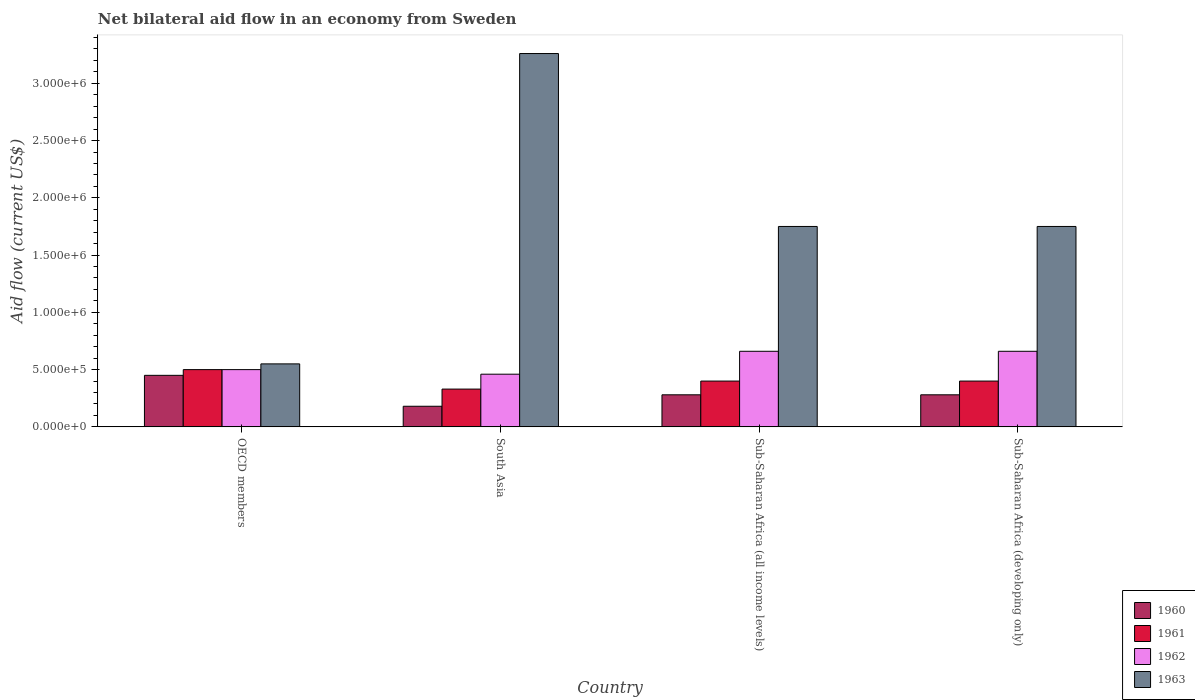How many different coloured bars are there?
Provide a succinct answer. 4. How many groups of bars are there?
Make the answer very short. 4. Are the number of bars per tick equal to the number of legend labels?
Make the answer very short. Yes. What is the label of the 4th group of bars from the left?
Ensure brevity in your answer.  Sub-Saharan Africa (developing only). In how many cases, is the number of bars for a given country not equal to the number of legend labels?
Provide a succinct answer. 0. In which country was the net bilateral aid flow in 1960 maximum?
Offer a terse response. OECD members. In which country was the net bilateral aid flow in 1963 minimum?
Your response must be concise. OECD members. What is the total net bilateral aid flow in 1960 in the graph?
Ensure brevity in your answer.  1.19e+06. What is the difference between the net bilateral aid flow in 1960 in Sub-Saharan Africa (all income levels) and that in Sub-Saharan Africa (developing only)?
Offer a terse response. 0. What is the difference between the net bilateral aid flow in 1961 in Sub-Saharan Africa (developing only) and the net bilateral aid flow in 1963 in Sub-Saharan Africa (all income levels)?
Give a very brief answer. -1.35e+06. What is the average net bilateral aid flow in 1961 per country?
Keep it short and to the point. 4.08e+05. In how many countries, is the net bilateral aid flow in 1961 greater than 200000 US$?
Provide a short and direct response. 4. What is the ratio of the net bilateral aid flow in 1962 in South Asia to that in Sub-Saharan Africa (all income levels)?
Your response must be concise. 0.7. Is the net bilateral aid flow in 1960 in South Asia less than that in Sub-Saharan Africa (all income levels)?
Make the answer very short. Yes. Is the difference between the net bilateral aid flow in 1962 in OECD members and Sub-Saharan Africa (developing only) greater than the difference between the net bilateral aid flow in 1963 in OECD members and Sub-Saharan Africa (developing only)?
Ensure brevity in your answer.  Yes. In how many countries, is the net bilateral aid flow in 1963 greater than the average net bilateral aid flow in 1963 taken over all countries?
Keep it short and to the point. 1. Is the sum of the net bilateral aid flow in 1963 in OECD members and South Asia greater than the maximum net bilateral aid flow in 1961 across all countries?
Give a very brief answer. Yes. Is it the case that in every country, the sum of the net bilateral aid flow in 1960 and net bilateral aid flow in 1961 is greater than the net bilateral aid flow in 1962?
Offer a terse response. Yes. How many bars are there?
Your answer should be compact. 16. Where does the legend appear in the graph?
Offer a very short reply. Bottom right. What is the title of the graph?
Ensure brevity in your answer.  Net bilateral aid flow in an economy from Sweden. What is the label or title of the X-axis?
Your answer should be compact. Country. What is the label or title of the Y-axis?
Give a very brief answer. Aid flow (current US$). What is the Aid flow (current US$) of 1960 in OECD members?
Give a very brief answer. 4.50e+05. What is the Aid flow (current US$) of 1963 in OECD members?
Keep it short and to the point. 5.50e+05. What is the Aid flow (current US$) of 1963 in South Asia?
Keep it short and to the point. 3.26e+06. What is the Aid flow (current US$) of 1960 in Sub-Saharan Africa (all income levels)?
Give a very brief answer. 2.80e+05. What is the Aid flow (current US$) in 1961 in Sub-Saharan Africa (all income levels)?
Your answer should be compact. 4.00e+05. What is the Aid flow (current US$) of 1962 in Sub-Saharan Africa (all income levels)?
Keep it short and to the point. 6.60e+05. What is the Aid flow (current US$) in 1963 in Sub-Saharan Africa (all income levels)?
Keep it short and to the point. 1.75e+06. What is the Aid flow (current US$) of 1960 in Sub-Saharan Africa (developing only)?
Keep it short and to the point. 2.80e+05. What is the Aid flow (current US$) in 1962 in Sub-Saharan Africa (developing only)?
Offer a terse response. 6.60e+05. What is the Aid flow (current US$) of 1963 in Sub-Saharan Africa (developing only)?
Offer a terse response. 1.75e+06. Across all countries, what is the maximum Aid flow (current US$) of 1960?
Provide a succinct answer. 4.50e+05. Across all countries, what is the maximum Aid flow (current US$) of 1961?
Your answer should be very brief. 5.00e+05. Across all countries, what is the maximum Aid flow (current US$) of 1962?
Give a very brief answer. 6.60e+05. Across all countries, what is the maximum Aid flow (current US$) in 1963?
Ensure brevity in your answer.  3.26e+06. Across all countries, what is the minimum Aid flow (current US$) in 1960?
Keep it short and to the point. 1.80e+05. Across all countries, what is the minimum Aid flow (current US$) of 1961?
Offer a very short reply. 3.30e+05. Across all countries, what is the minimum Aid flow (current US$) of 1962?
Ensure brevity in your answer.  4.60e+05. What is the total Aid flow (current US$) of 1960 in the graph?
Offer a terse response. 1.19e+06. What is the total Aid flow (current US$) in 1961 in the graph?
Your answer should be compact. 1.63e+06. What is the total Aid flow (current US$) of 1962 in the graph?
Keep it short and to the point. 2.28e+06. What is the total Aid flow (current US$) of 1963 in the graph?
Your answer should be very brief. 7.31e+06. What is the difference between the Aid flow (current US$) in 1963 in OECD members and that in South Asia?
Your response must be concise. -2.71e+06. What is the difference between the Aid flow (current US$) of 1962 in OECD members and that in Sub-Saharan Africa (all income levels)?
Your response must be concise. -1.60e+05. What is the difference between the Aid flow (current US$) in 1963 in OECD members and that in Sub-Saharan Africa (all income levels)?
Offer a very short reply. -1.20e+06. What is the difference between the Aid flow (current US$) in 1963 in OECD members and that in Sub-Saharan Africa (developing only)?
Ensure brevity in your answer.  -1.20e+06. What is the difference between the Aid flow (current US$) in 1961 in South Asia and that in Sub-Saharan Africa (all income levels)?
Ensure brevity in your answer.  -7.00e+04. What is the difference between the Aid flow (current US$) of 1963 in South Asia and that in Sub-Saharan Africa (all income levels)?
Provide a succinct answer. 1.51e+06. What is the difference between the Aid flow (current US$) in 1960 in South Asia and that in Sub-Saharan Africa (developing only)?
Give a very brief answer. -1.00e+05. What is the difference between the Aid flow (current US$) in 1962 in South Asia and that in Sub-Saharan Africa (developing only)?
Provide a succinct answer. -2.00e+05. What is the difference between the Aid flow (current US$) in 1963 in South Asia and that in Sub-Saharan Africa (developing only)?
Provide a short and direct response. 1.51e+06. What is the difference between the Aid flow (current US$) in 1960 in OECD members and the Aid flow (current US$) in 1963 in South Asia?
Ensure brevity in your answer.  -2.81e+06. What is the difference between the Aid flow (current US$) in 1961 in OECD members and the Aid flow (current US$) in 1962 in South Asia?
Provide a short and direct response. 4.00e+04. What is the difference between the Aid flow (current US$) of 1961 in OECD members and the Aid flow (current US$) of 1963 in South Asia?
Make the answer very short. -2.76e+06. What is the difference between the Aid flow (current US$) in 1962 in OECD members and the Aid flow (current US$) in 1963 in South Asia?
Provide a short and direct response. -2.76e+06. What is the difference between the Aid flow (current US$) of 1960 in OECD members and the Aid flow (current US$) of 1963 in Sub-Saharan Africa (all income levels)?
Your answer should be compact. -1.30e+06. What is the difference between the Aid flow (current US$) of 1961 in OECD members and the Aid flow (current US$) of 1962 in Sub-Saharan Africa (all income levels)?
Your answer should be compact. -1.60e+05. What is the difference between the Aid flow (current US$) in 1961 in OECD members and the Aid flow (current US$) in 1963 in Sub-Saharan Africa (all income levels)?
Give a very brief answer. -1.25e+06. What is the difference between the Aid flow (current US$) in 1962 in OECD members and the Aid flow (current US$) in 1963 in Sub-Saharan Africa (all income levels)?
Your response must be concise. -1.25e+06. What is the difference between the Aid flow (current US$) of 1960 in OECD members and the Aid flow (current US$) of 1961 in Sub-Saharan Africa (developing only)?
Your answer should be very brief. 5.00e+04. What is the difference between the Aid flow (current US$) of 1960 in OECD members and the Aid flow (current US$) of 1963 in Sub-Saharan Africa (developing only)?
Provide a short and direct response. -1.30e+06. What is the difference between the Aid flow (current US$) in 1961 in OECD members and the Aid flow (current US$) in 1962 in Sub-Saharan Africa (developing only)?
Keep it short and to the point. -1.60e+05. What is the difference between the Aid flow (current US$) of 1961 in OECD members and the Aid flow (current US$) of 1963 in Sub-Saharan Africa (developing only)?
Your answer should be compact. -1.25e+06. What is the difference between the Aid flow (current US$) of 1962 in OECD members and the Aid flow (current US$) of 1963 in Sub-Saharan Africa (developing only)?
Your answer should be very brief. -1.25e+06. What is the difference between the Aid flow (current US$) in 1960 in South Asia and the Aid flow (current US$) in 1962 in Sub-Saharan Africa (all income levels)?
Give a very brief answer. -4.80e+05. What is the difference between the Aid flow (current US$) of 1960 in South Asia and the Aid flow (current US$) of 1963 in Sub-Saharan Africa (all income levels)?
Provide a succinct answer. -1.57e+06. What is the difference between the Aid flow (current US$) of 1961 in South Asia and the Aid flow (current US$) of 1962 in Sub-Saharan Africa (all income levels)?
Ensure brevity in your answer.  -3.30e+05. What is the difference between the Aid flow (current US$) in 1961 in South Asia and the Aid flow (current US$) in 1963 in Sub-Saharan Africa (all income levels)?
Ensure brevity in your answer.  -1.42e+06. What is the difference between the Aid flow (current US$) in 1962 in South Asia and the Aid flow (current US$) in 1963 in Sub-Saharan Africa (all income levels)?
Make the answer very short. -1.29e+06. What is the difference between the Aid flow (current US$) of 1960 in South Asia and the Aid flow (current US$) of 1962 in Sub-Saharan Africa (developing only)?
Provide a short and direct response. -4.80e+05. What is the difference between the Aid flow (current US$) of 1960 in South Asia and the Aid flow (current US$) of 1963 in Sub-Saharan Africa (developing only)?
Provide a short and direct response. -1.57e+06. What is the difference between the Aid flow (current US$) of 1961 in South Asia and the Aid flow (current US$) of 1962 in Sub-Saharan Africa (developing only)?
Offer a very short reply. -3.30e+05. What is the difference between the Aid flow (current US$) in 1961 in South Asia and the Aid flow (current US$) in 1963 in Sub-Saharan Africa (developing only)?
Your answer should be compact. -1.42e+06. What is the difference between the Aid flow (current US$) of 1962 in South Asia and the Aid flow (current US$) of 1963 in Sub-Saharan Africa (developing only)?
Provide a short and direct response. -1.29e+06. What is the difference between the Aid flow (current US$) in 1960 in Sub-Saharan Africa (all income levels) and the Aid flow (current US$) in 1961 in Sub-Saharan Africa (developing only)?
Your answer should be compact. -1.20e+05. What is the difference between the Aid flow (current US$) of 1960 in Sub-Saharan Africa (all income levels) and the Aid flow (current US$) of 1962 in Sub-Saharan Africa (developing only)?
Provide a succinct answer. -3.80e+05. What is the difference between the Aid flow (current US$) of 1960 in Sub-Saharan Africa (all income levels) and the Aid flow (current US$) of 1963 in Sub-Saharan Africa (developing only)?
Offer a terse response. -1.47e+06. What is the difference between the Aid flow (current US$) in 1961 in Sub-Saharan Africa (all income levels) and the Aid flow (current US$) in 1963 in Sub-Saharan Africa (developing only)?
Make the answer very short. -1.35e+06. What is the difference between the Aid flow (current US$) of 1962 in Sub-Saharan Africa (all income levels) and the Aid flow (current US$) of 1963 in Sub-Saharan Africa (developing only)?
Your answer should be compact. -1.09e+06. What is the average Aid flow (current US$) of 1960 per country?
Offer a very short reply. 2.98e+05. What is the average Aid flow (current US$) of 1961 per country?
Offer a terse response. 4.08e+05. What is the average Aid flow (current US$) of 1962 per country?
Ensure brevity in your answer.  5.70e+05. What is the average Aid flow (current US$) of 1963 per country?
Your answer should be compact. 1.83e+06. What is the difference between the Aid flow (current US$) in 1961 and Aid flow (current US$) in 1962 in OECD members?
Offer a very short reply. 0. What is the difference between the Aid flow (current US$) of 1961 and Aid flow (current US$) of 1963 in OECD members?
Your answer should be very brief. -5.00e+04. What is the difference between the Aid flow (current US$) of 1960 and Aid flow (current US$) of 1961 in South Asia?
Keep it short and to the point. -1.50e+05. What is the difference between the Aid flow (current US$) in 1960 and Aid flow (current US$) in 1962 in South Asia?
Offer a very short reply. -2.80e+05. What is the difference between the Aid flow (current US$) of 1960 and Aid flow (current US$) of 1963 in South Asia?
Keep it short and to the point. -3.08e+06. What is the difference between the Aid flow (current US$) in 1961 and Aid flow (current US$) in 1962 in South Asia?
Your answer should be compact. -1.30e+05. What is the difference between the Aid flow (current US$) in 1961 and Aid flow (current US$) in 1963 in South Asia?
Ensure brevity in your answer.  -2.93e+06. What is the difference between the Aid flow (current US$) of 1962 and Aid flow (current US$) of 1963 in South Asia?
Your response must be concise. -2.80e+06. What is the difference between the Aid flow (current US$) in 1960 and Aid flow (current US$) in 1962 in Sub-Saharan Africa (all income levels)?
Provide a succinct answer. -3.80e+05. What is the difference between the Aid flow (current US$) in 1960 and Aid flow (current US$) in 1963 in Sub-Saharan Africa (all income levels)?
Keep it short and to the point. -1.47e+06. What is the difference between the Aid flow (current US$) of 1961 and Aid flow (current US$) of 1963 in Sub-Saharan Africa (all income levels)?
Your answer should be compact. -1.35e+06. What is the difference between the Aid flow (current US$) in 1962 and Aid flow (current US$) in 1963 in Sub-Saharan Africa (all income levels)?
Offer a terse response. -1.09e+06. What is the difference between the Aid flow (current US$) in 1960 and Aid flow (current US$) in 1961 in Sub-Saharan Africa (developing only)?
Ensure brevity in your answer.  -1.20e+05. What is the difference between the Aid flow (current US$) of 1960 and Aid flow (current US$) of 1962 in Sub-Saharan Africa (developing only)?
Offer a very short reply. -3.80e+05. What is the difference between the Aid flow (current US$) of 1960 and Aid flow (current US$) of 1963 in Sub-Saharan Africa (developing only)?
Your answer should be compact. -1.47e+06. What is the difference between the Aid flow (current US$) of 1961 and Aid flow (current US$) of 1962 in Sub-Saharan Africa (developing only)?
Make the answer very short. -2.60e+05. What is the difference between the Aid flow (current US$) in 1961 and Aid flow (current US$) in 1963 in Sub-Saharan Africa (developing only)?
Offer a very short reply. -1.35e+06. What is the difference between the Aid flow (current US$) of 1962 and Aid flow (current US$) of 1963 in Sub-Saharan Africa (developing only)?
Provide a succinct answer. -1.09e+06. What is the ratio of the Aid flow (current US$) in 1961 in OECD members to that in South Asia?
Offer a very short reply. 1.52. What is the ratio of the Aid flow (current US$) of 1962 in OECD members to that in South Asia?
Keep it short and to the point. 1.09. What is the ratio of the Aid flow (current US$) of 1963 in OECD members to that in South Asia?
Keep it short and to the point. 0.17. What is the ratio of the Aid flow (current US$) in 1960 in OECD members to that in Sub-Saharan Africa (all income levels)?
Provide a short and direct response. 1.61. What is the ratio of the Aid flow (current US$) of 1962 in OECD members to that in Sub-Saharan Africa (all income levels)?
Offer a very short reply. 0.76. What is the ratio of the Aid flow (current US$) of 1963 in OECD members to that in Sub-Saharan Africa (all income levels)?
Make the answer very short. 0.31. What is the ratio of the Aid flow (current US$) in 1960 in OECD members to that in Sub-Saharan Africa (developing only)?
Give a very brief answer. 1.61. What is the ratio of the Aid flow (current US$) in 1961 in OECD members to that in Sub-Saharan Africa (developing only)?
Make the answer very short. 1.25. What is the ratio of the Aid flow (current US$) in 1962 in OECD members to that in Sub-Saharan Africa (developing only)?
Ensure brevity in your answer.  0.76. What is the ratio of the Aid flow (current US$) of 1963 in OECD members to that in Sub-Saharan Africa (developing only)?
Your answer should be very brief. 0.31. What is the ratio of the Aid flow (current US$) in 1960 in South Asia to that in Sub-Saharan Africa (all income levels)?
Provide a succinct answer. 0.64. What is the ratio of the Aid flow (current US$) of 1961 in South Asia to that in Sub-Saharan Africa (all income levels)?
Give a very brief answer. 0.82. What is the ratio of the Aid flow (current US$) of 1962 in South Asia to that in Sub-Saharan Africa (all income levels)?
Give a very brief answer. 0.7. What is the ratio of the Aid flow (current US$) of 1963 in South Asia to that in Sub-Saharan Africa (all income levels)?
Ensure brevity in your answer.  1.86. What is the ratio of the Aid flow (current US$) of 1960 in South Asia to that in Sub-Saharan Africa (developing only)?
Provide a succinct answer. 0.64. What is the ratio of the Aid flow (current US$) in 1961 in South Asia to that in Sub-Saharan Africa (developing only)?
Offer a terse response. 0.82. What is the ratio of the Aid flow (current US$) in 1962 in South Asia to that in Sub-Saharan Africa (developing only)?
Give a very brief answer. 0.7. What is the ratio of the Aid flow (current US$) in 1963 in South Asia to that in Sub-Saharan Africa (developing only)?
Your answer should be very brief. 1.86. What is the ratio of the Aid flow (current US$) in 1960 in Sub-Saharan Africa (all income levels) to that in Sub-Saharan Africa (developing only)?
Keep it short and to the point. 1. What is the ratio of the Aid flow (current US$) in 1962 in Sub-Saharan Africa (all income levels) to that in Sub-Saharan Africa (developing only)?
Offer a very short reply. 1. What is the ratio of the Aid flow (current US$) in 1963 in Sub-Saharan Africa (all income levels) to that in Sub-Saharan Africa (developing only)?
Your answer should be compact. 1. What is the difference between the highest and the second highest Aid flow (current US$) of 1961?
Provide a short and direct response. 1.00e+05. What is the difference between the highest and the second highest Aid flow (current US$) of 1962?
Ensure brevity in your answer.  0. What is the difference between the highest and the second highest Aid flow (current US$) in 1963?
Offer a terse response. 1.51e+06. What is the difference between the highest and the lowest Aid flow (current US$) of 1962?
Make the answer very short. 2.00e+05. What is the difference between the highest and the lowest Aid flow (current US$) of 1963?
Give a very brief answer. 2.71e+06. 